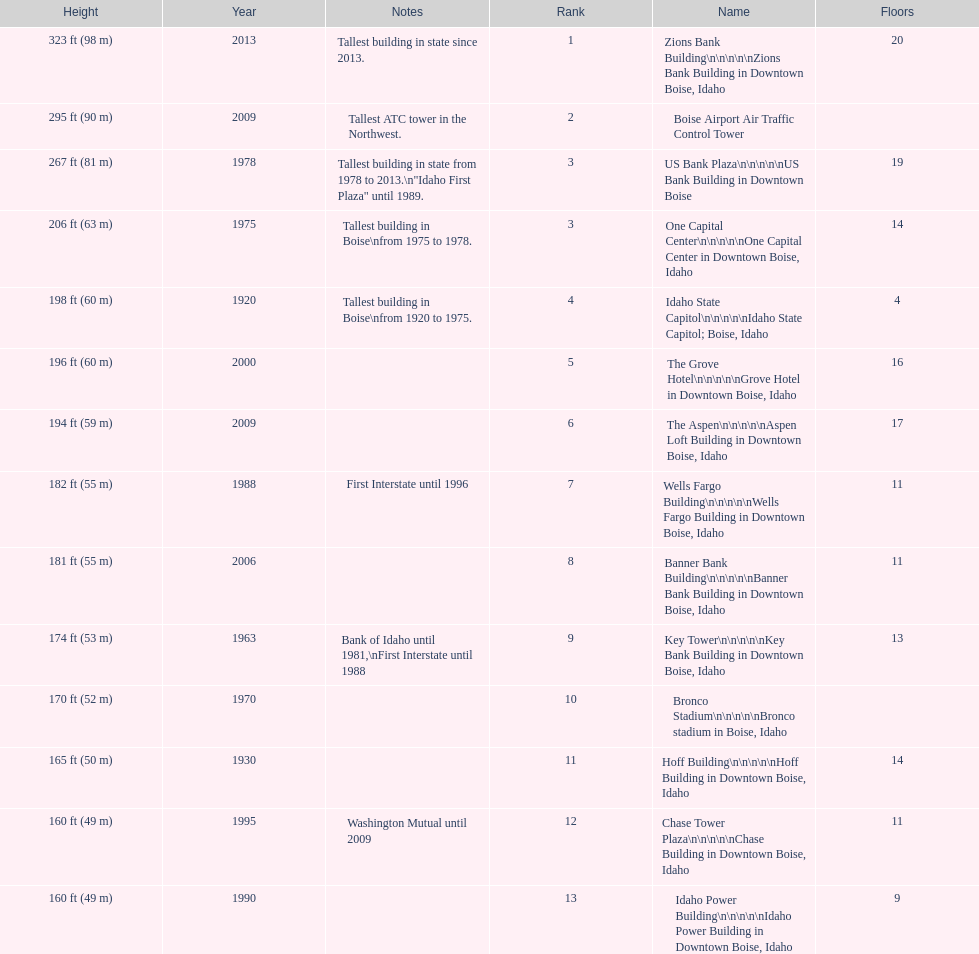What are the number of floors the us bank plaza has? 19. Help me parse the entirety of this table. {'header': ['Height', 'Year', 'Notes', 'Rank', 'Name', 'Floors'], 'rows': [['323\xa0ft (98\xa0m)', '2013', 'Tallest building in state since 2013.', '1', 'Zions Bank Building\\n\\n\\n\\n\\nZions Bank Building in Downtown Boise, Idaho', '20'], ['295\xa0ft (90\xa0m)', '2009', 'Tallest ATC tower in the Northwest.', '2', 'Boise Airport Air Traffic Control Tower', ''], ['267\xa0ft (81\xa0m)', '1978', 'Tallest building in state from 1978 to 2013.\\n"Idaho First Plaza" until 1989.', '3', 'US Bank Plaza\\n\\n\\n\\n\\nUS Bank Building in Downtown Boise', '19'], ['206\xa0ft (63\xa0m)', '1975', 'Tallest building in Boise\\nfrom 1975 to 1978.', '3', 'One Capital Center\\n\\n\\n\\n\\nOne Capital Center in Downtown Boise, Idaho', '14'], ['198\xa0ft (60\xa0m)', '1920', 'Tallest building in Boise\\nfrom 1920 to 1975.', '4', 'Idaho State Capitol\\n\\n\\n\\n\\nIdaho State Capitol; Boise, Idaho', '4'], ['196\xa0ft (60\xa0m)', '2000', '', '5', 'The Grove Hotel\\n\\n\\n\\n\\nGrove Hotel in Downtown Boise, Idaho', '16'], ['194\xa0ft (59\xa0m)', '2009', '', '6', 'The Aspen\\n\\n\\n\\n\\nAspen Loft Building in Downtown Boise, Idaho', '17'], ['182\xa0ft (55\xa0m)', '1988', 'First Interstate until 1996', '7', 'Wells Fargo Building\\n\\n\\n\\n\\nWells Fargo Building in Downtown Boise, Idaho', '11'], ['181\xa0ft (55\xa0m)', '2006', '', '8', 'Banner Bank Building\\n\\n\\n\\n\\nBanner Bank Building in Downtown Boise, Idaho', '11'], ['174\xa0ft (53\xa0m)', '1963', 'Bank of Idaho until 1981,\\nFirst Interstate until 1988', '9', 'Key Tower\\n\\n\\n\\n\\nKey Bank Building in Downtown Boise, Idaho', '13'], ['170\xa0ft (52\xa0m)', '1970', '', '10', 'Bronco Stadium\\n\\n\\n\\n\\nBronco stadium in Boise, Idaho', ''], ['165\xa0ft (50\xa0m)', '1930', '', '11', 'Hoff Building\\n\\n\\n\\n\\nHoff Building in Downtown Boise, Idaho', '14'], ['160\xa0ft (49\xa0m)', '1995', 'Washington Mutual until 2009', '12', 'Chase Tower Plaza\\n\\n\\n\\n\\nChase Building in Downtown Boise, Idaho', '11'], ['160\xa0ft (49\xa0m)', '1990', '', '13', 'Idaho Power Building\\n\\n\\n\\n\\nIdaho Power Building in Downtown Boise, Idaho', '9']]} 